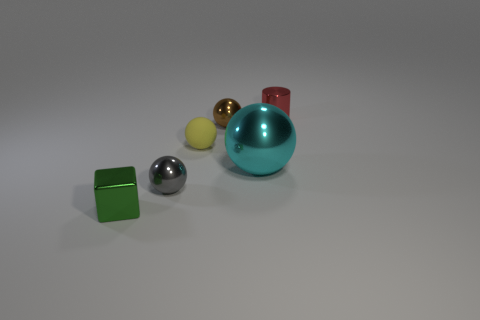Subtract all small yellow rubber balls. How many balls are left? 3 Add 3 metal spheres. How many objects exist? 9 Subtract all cyan balls. How many balls are left? 3 Subtract 1 spheres. How many spheres are left? 3 Subtract 1 brown balls. How many objects are left? 5 Subtract all balls. How many objects are left? 2 Subtract all gray balls. Subtract all brown blocks. How many balls are left? 3 Subtract all green matte things. Subtract all large cyan things. How many objects are left? 5 Add 6 tiny red metallic things. How many tiny red metallic things are left? 7 Add 6 tiny matte balls. How many tiny matte balls exist? 7 